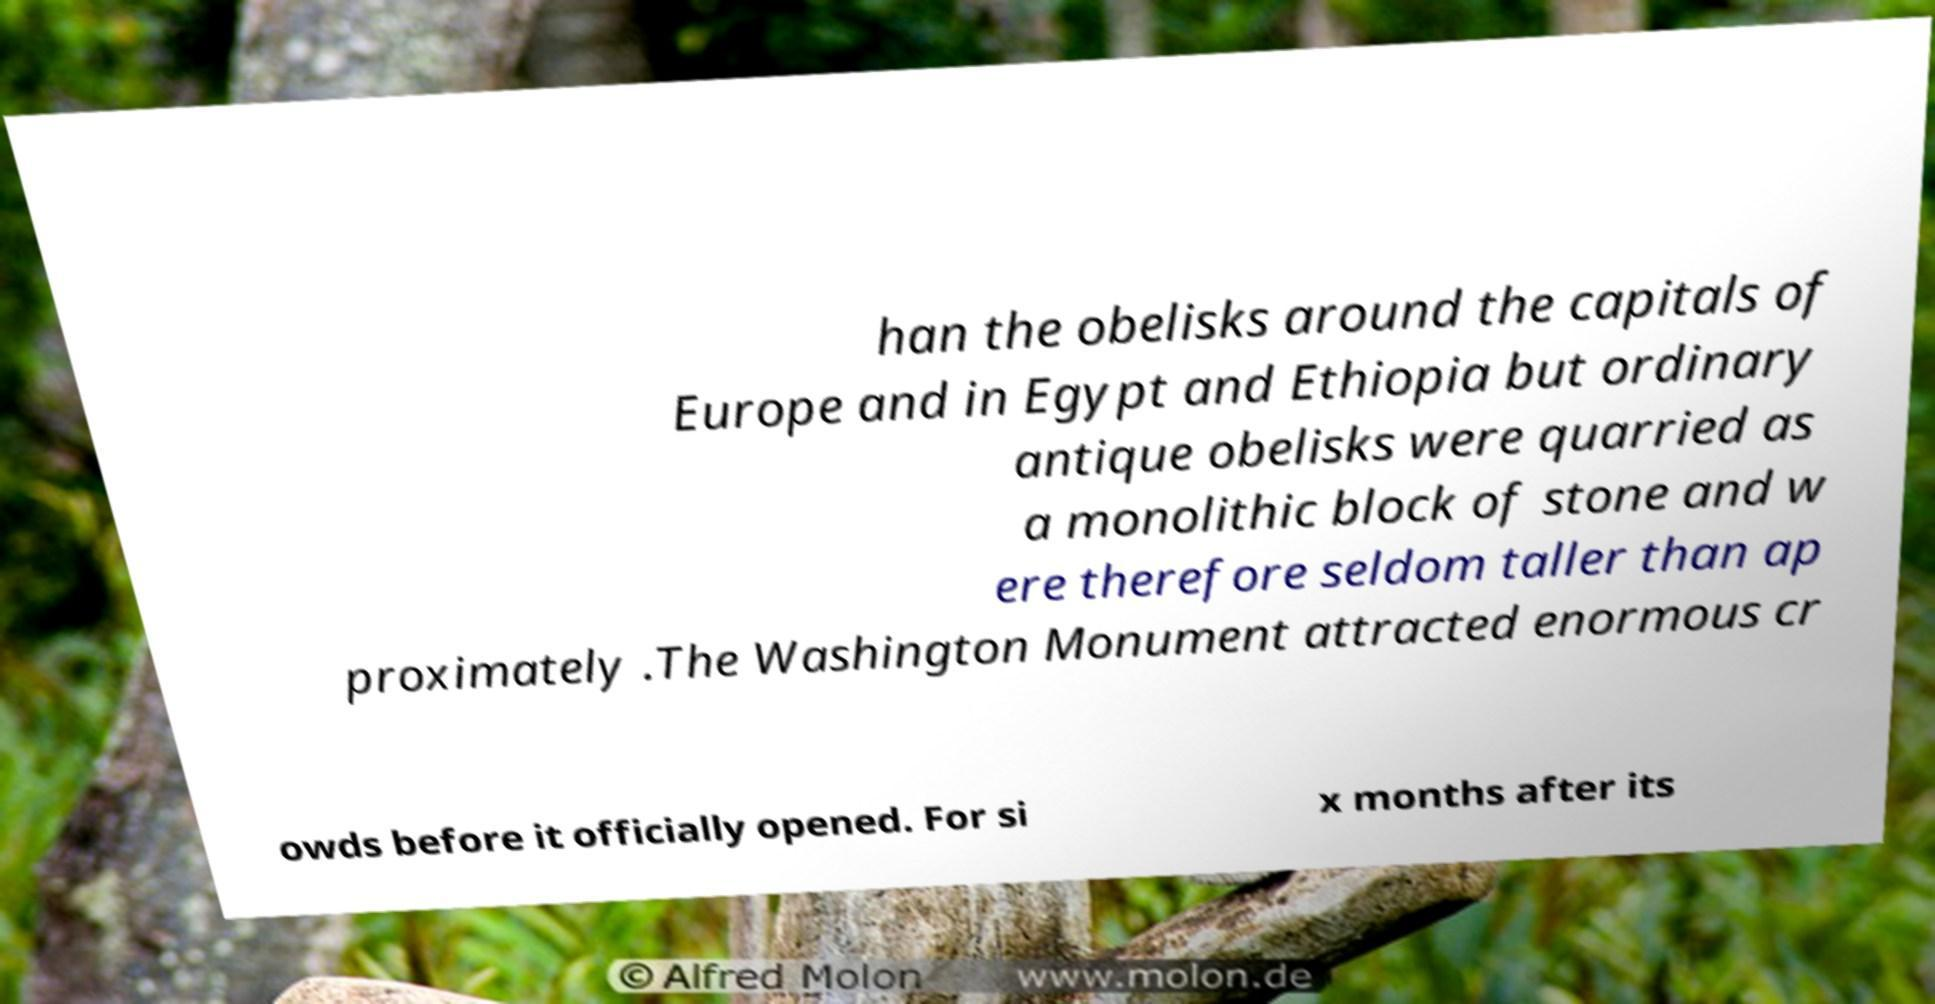Can you accurately transcribe the text from the provided image for me? han the obelisks around the capitals of Europe and in Egypt and Ethiopia but ordinary antique obelisks were quarried as a monolithic block of stone and w ere therefore seldom taller than ap proximately .The Washington Monument attracted enormous cr owds before it officially opened. For si x months after its 